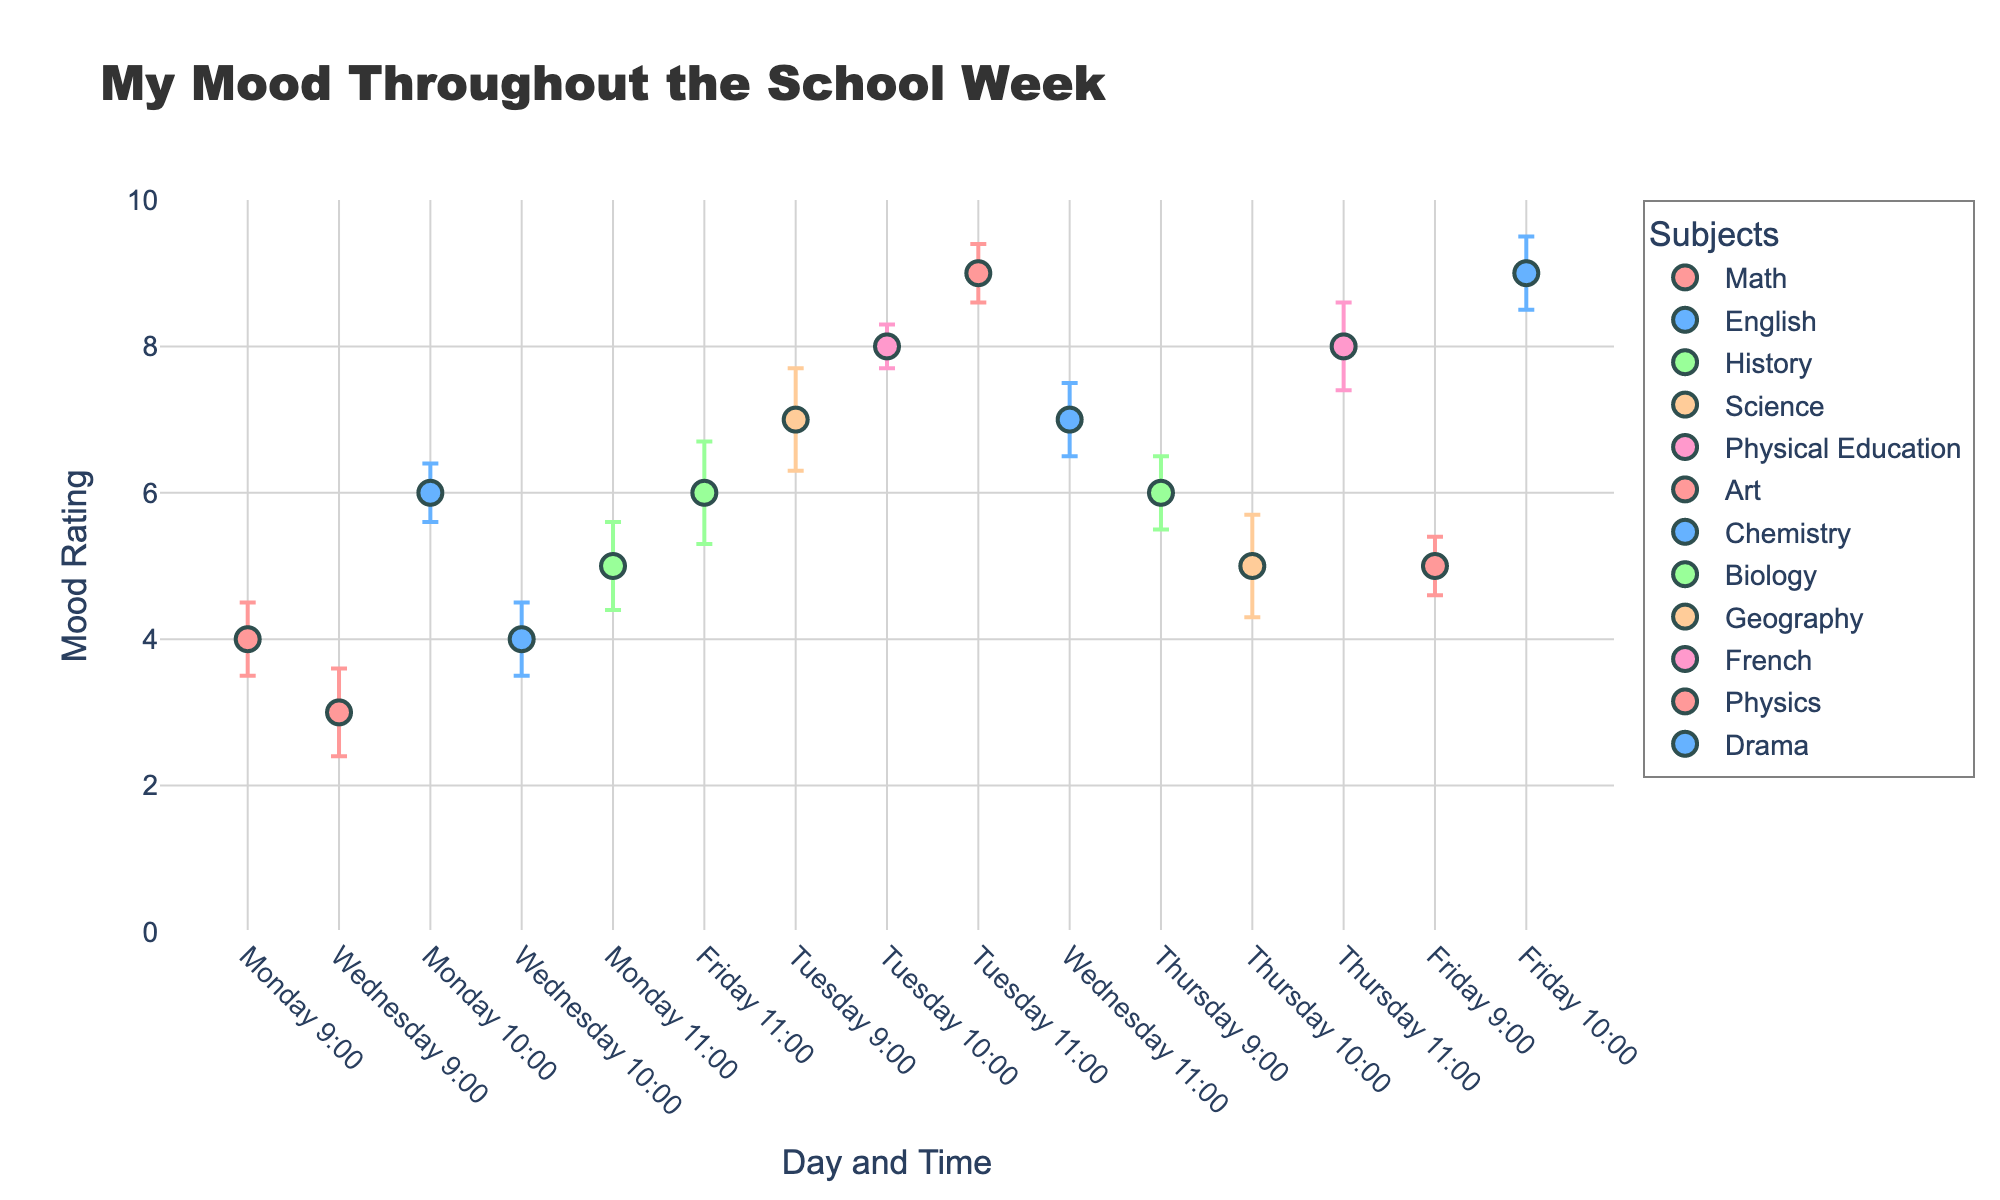What is the title of the scatter plot? The title is usually displayed at the top of the plot. In this case, it reads, "My Mood Throughout the School Week."
Answer: My Mood Throughout the School Week What days have the data points for Math classes? We need to check the labels on the x-axis to see which days have data points for Math. Math data points are labeled on Monday and Wednesday.
Answer: Monday and Wednesday Which subject has the highest mood rating? To answer this, we scan the y-axis for the highest value. Art on Tuesday at 11:00 has a mood rating of 9.
Answer: Art What is the mood rating for Drama on Friday at 10:00? Look for the marker corresponding to Drama on the x-axis, Friday at 10:00, and find the y-position of that marker, which is 9.
Answer: 9 Which subject shows the highest error in mood rating? We need to check the error bars and find the one with the largest value. Science on Tuesday at 9:00 shows the highest error of 0.7.
Answer: Science On which day is the average mood rating the lowest? First, note the mood ratings per day. Monday: 4, 6, 5; Tuesday: 7, 8, 9; Wednesday: 3, 4, 7; Thursday: 6, 5, 8; Friday: 5, 9, 6. Calculate the average for each day. Monday: (4+6+5)/3 = 5, Tuesday: (7+8+9)/3 = 8, Wednesday: (3+4+7)/3 = 4.67, Thursday: (6+5+8)/3 = 6.33, Friday: (5+9+6)/3 = 6.67. The lowest average mood rating is on Wednesday.
Answer: Wednesday Which day shows the most consistent mood ratings, judging by error bars? Consistency is represented by smaller error bars. Tuesday's error bars are 0.7, 0.3, 0.4; Monday's are 0.5, 0.4, 0.6; Wednesday's are 0.6, 0.5, 0.5; Thursday's are 0.5, 0.7, 0.6; Friday's are 0.4, 0.5, 0.7. Tuesday has the smallest total error (1.4) and thus is most consistent.
Answer: Tuesday What is the mood rating for History on Monday? Locate the History marker on Monday and check its mood rating on the y-axis, which is 5.
Answer: 5 Compare the mood ratings of Math on Monday and Wednesday. Math mood rating on Monday is 4, and on Wednesday is 3. Thus, the mood rating for Math on Monday is higher.
Answer: Monday has a higher mood rating for Math Which subject has a mood rating of 8? Checking all data points, Physical Education on Tuesday at 10:00 and French on Thursday at 11:00 both have mood ratings of 8.
Answer: Physical Education and French 